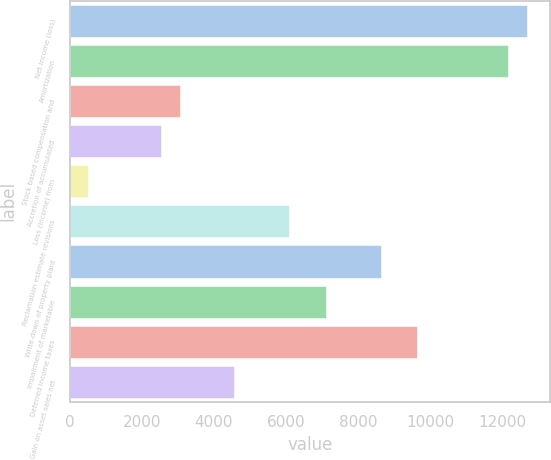<chart> <loc_0><loc_0><loc_500><loc_500><bar_chart><fcel>Net income (loss)<fcel>Amortization<fcel>Stock based compensation and<fcel>Accretion of accumulated<fcel>Loss (income) from<fcel>Reclamation estimate revisions<fcel>Write-down of property plant<fcel>Impairment of marketable<fcel>Deferred income taxes<fcel>Gain on asset sales net<nl><fcel>12689<fcel>12181.6<fcel>3048.4<fcel>2541<fcel>511.4<fcel>6092.8<fcel>8629.8<fcel>7107.6<fcel>9644.6<fcel>4570.6<nl></chart> 